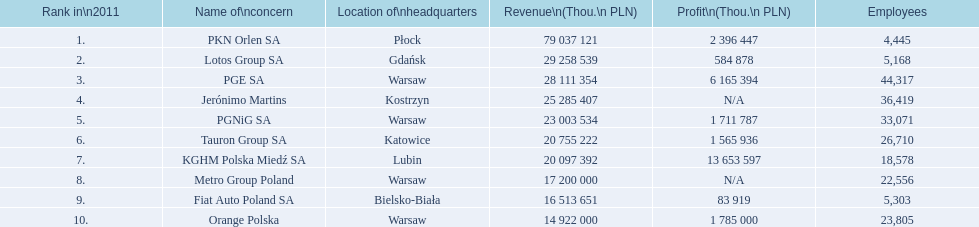What is the employee count for pkn orlen sa in poland? 4,445. How many staff members does lotos group sa have? 5,168. What is the number of workers at pgnig sa? 33,071. 